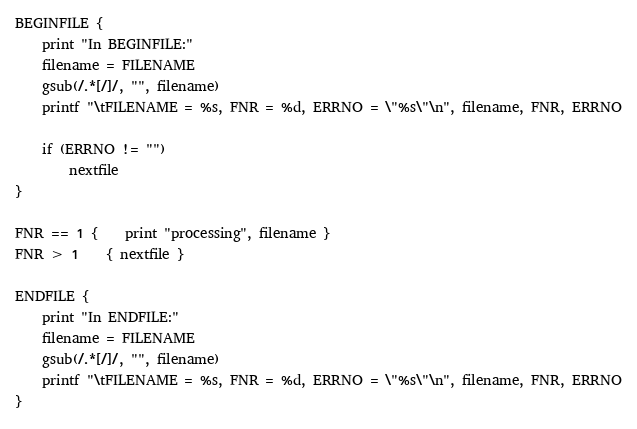Convert code to text. <code><loc_0><loc_0><loc_500><loc_500><_Awk_>BEGINFILE {
	print "In BEGINFILE:"
	filename = FILENAME
	gsub(/.*[/]/, "", filename)
	printf "\tFILENAME = %s, FNR = %d, ERRNO = \"%s\"\n", filename, FNR, ERRNO

	if (ERRNO != "")
		nextfile
}

FNR == 1 {	print "processing", filename }
FNR > 1	{ nextfile }

ENDFILE {
	print "In ENDFILE:"
	filename = FILENAME
	gsub(/.*[/]/, "", filename)
	printf "\tFILENAME = %s, FNR = %d, ERRNO = \"%s\"\n", filename, FNR, ERRNO
}
</code> 